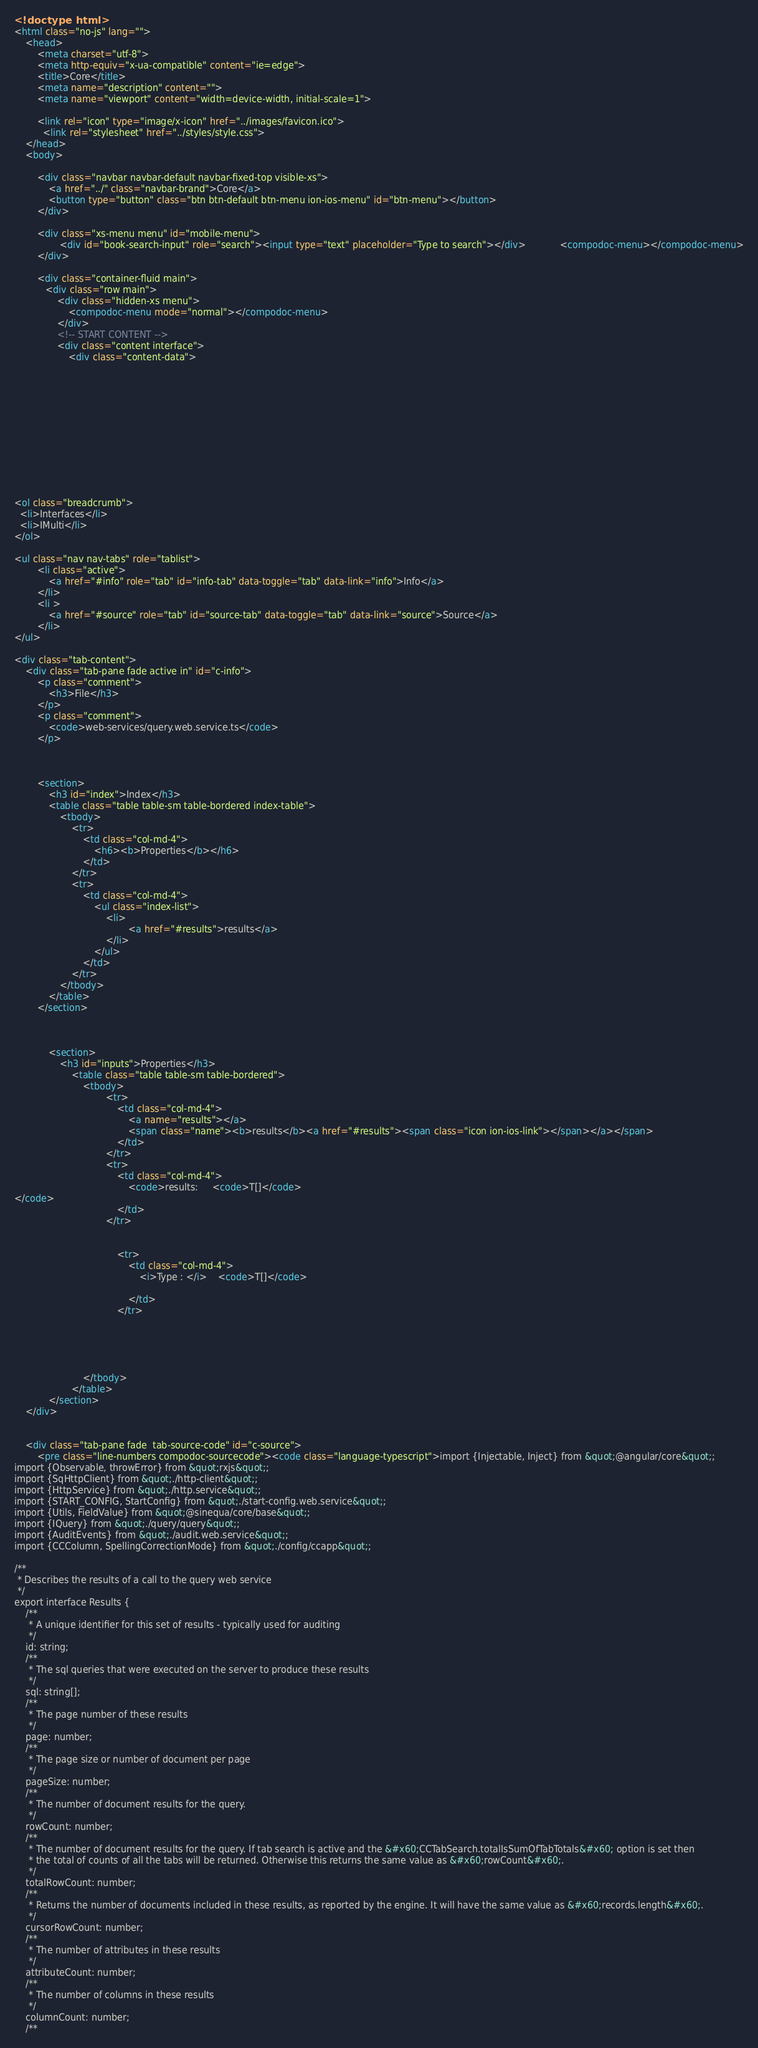<code> <loc_0><loc_0><loc_500><loc_500><_HTML_><!doctype html>
<html class="no-js" lang="">
    <head>
        <meta charset="utf-8">
        <meta http-equiv="x-ua-compatible" content="ie=edge">
        <title>Core</title>
        <meta name="description" content="">
        <meta name="viewport" content="width=device-width, initial-scale=1">

        <link rel="icon" type="image/x-icon" href="../images/favicon.ico">
	      <link rel="stylesheet" href="../styles/style.css">
    </head>
    <body>

        <div class="navbar navbar-default navbar-fixed-top visible-xs">
            <a href="../" class="navbar-brand">Core</a>
            <button type="button" class="btn btn-default btn-menu ion-ios-menu" id="btn-menu"></button>
        </div>

        <div class="xs-menu menu" id="mobile-menu">
                <div id="book-search-input" role="search"><input type="text" placeholder="Type to search"></div>            <compodoc-menu></compodoc-menu>
        </div>

        <div class="container-fluid main">
           <div class="row main">
               <div class="hidden-xs menu">
                   <compodoc-menu mode="normal"></compodoc-menu>
               </div>
               <!-- START CONTENT -->
               <div class="content interface">
                   <div class="content-data">












<ol class="breadcrumb">
  <li>Interfaces</li>
  <li>IMulti</li>
</ol>

<ul class="nav nav-tabs" role="tablist">
        <li class="active">
            <a href="#info" role="tab" id="info-tab" data-toggle="tab" data-link="info">Info</a>
        </li>
        <li >
            <a href="#source" role="tab" id="source-tab" data-toggle="tab" data-link="source">Source</a>
        </li>
</ul>

<div class="tab-content">
    <div class="tab-pane fade active in" id="c-info">
        <p class="comment">
            <h3>File</h3>
        </p>
        <p class="comment">
            <code>web-services/query.web.service.ts</code>
        </p>



        <section>
            <h3 id="index">Index</h3>
            <table class="table table-sm table-bordered index-table">
                <tbody>
                    <tr>
                        <td class="col-md-4">
                            <h6><b>Properties</b></h6>
                        </td>
                    </tr>
                    <tr>
                        <td class="col-md-4">
                            <ul class="index-list">
                                <li>
                                        <a href="#results">results</a>
                                </li>
                            </ul>
                        </td>
                    </tr>
                </tbody>
            </table>
        </section>



            <section>
                <h3 id="inputs">Properties</h3>
                    <table class="table table-sm table-bordered">
                        <tbody>
                                <tr>
                                    <td class="col-md-4">
                                        <a name="results"></a>
                                        <span class="name"><b>results</b><a href="#results"><span class="icon ion-ios-link"></span></a></span>
                                    </td>
                                </tr>
                                <tr>
                                    <td class="col-md-4">
                                        <code>results:     <code>T[]</code>
</code>
                                    </td>
                                </tr>


                                    <tr>
                                        <td class="col-md-4">
                                            <i>Type : </i>    <code>T[]</code>

                                        </td>
                                    </tr>





                        </tbody>
                    </table>
            </section>
    </div>


    <div class="tab-pane fade  tab-source-code" id="c-source">
        <pre class="line-numbers compodoc-sourcecode"><code class="language-typescript">import {Injectable, Inject} from &quot;@angular/core&quot;;
import {Observable, throwError} from &quot;rxjs&quot;;
import {SqHttpClient} from &quot;./http-client&quot;;
import {HttpService} from &quot;./http.service&quot;;
import {START_CONFIG, StartConfig} from &quot;./start-config.web.service&quot;;
import {Utils, FieldValue} from &quot;@sinequa/core/base&quot;;
import {IQuery} from &quot;./query/query&quot;;
import {AuditEvents} from &quot;./audit.web.service&quot;;
import {CCColumn, SpellingCorrectionMode} from &quot;./config/ccapp&quot;;

/**
 * Describes the results of a call to the query web service
 */
export interface Results {
    /**
     * A unique identifier for this set of results - typically used for auditing
     */
    id: string;
    /**
     * The sql queries that were executed on the server to produce these results
     */
    sql: string[];
    /**
     * The page number of these results
     */
    page: number;
    /**
     * The page size or number of document per page
     */
    pageSize: number;
    /**
     * The number of document results for the query.
     */
    rowCount: number;
    /**
     * The number of document results for the query. If tab search is active and the &#x60;CCTabSearch.totalIsSumOfTabTotals&#x60; option is set then
     * the total of counts of all the tabs will be returned. Otherwise this returns the same value as &#x60;rowCount&#x60;.
     */
    totalRowCount: number;
    /**
     * Returns the number of documents included in these results, as reported by the engine. It will have the same value as &#x60;records.length&#x60;.
     */
    cursorRowCount: number;
    /**
     * The number of attributes in these results
     */
    attributeCount: number;
    /**
     * The number of columns in these results
     */
    columnCount: number;
    /**</code> 